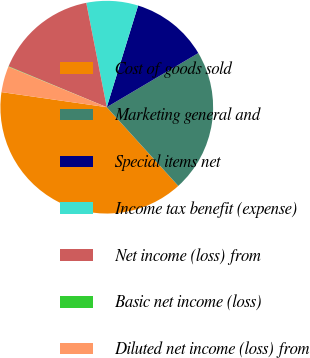Convert chart. <chart><loc_0><loc_0><loc_500><loc_500><pie_chart><fcel>Cost of goods sold<fcel>Marketing general and<fcel>Special items net<fcel>Income tax benefit (expense)<fcel>Net income (loss) from<fcel>Basic net income (loss)<fcel>Diluted net income (loss) from<nl><fcel>39.01%<fcel>21.76%<fcel>11.74%<fcel>7.85%<fcel>15.64%<fcel>0.06%<fcel>3.95%<nl></chart> 